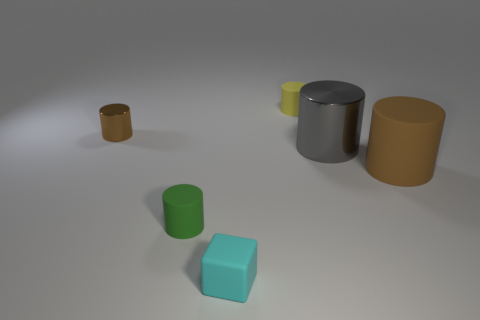Subtract all yellow matte cylinders. How many cylinders are left? 4 Subtract all green cylinders. How many cylinders are left? 4 Add 4 brown things. How many objects exist? 10 Subtract all purple blocks. How many green cylinders are left? 1 Add 6 big matte objects. How many big matte objects are left? 7 Add 1 cyan metallic blocks. How many cyan metallic blocks exist? 1 Subtract 0 gray spheres. How many objects are left? 6 Subtract all cylinders. How many objects are left? 1 Subtract 2 cylinders. How many cylinders are left? 3 Subtract all red cylinders. Subtract all brown spheres. How many cylinders are left? 5 